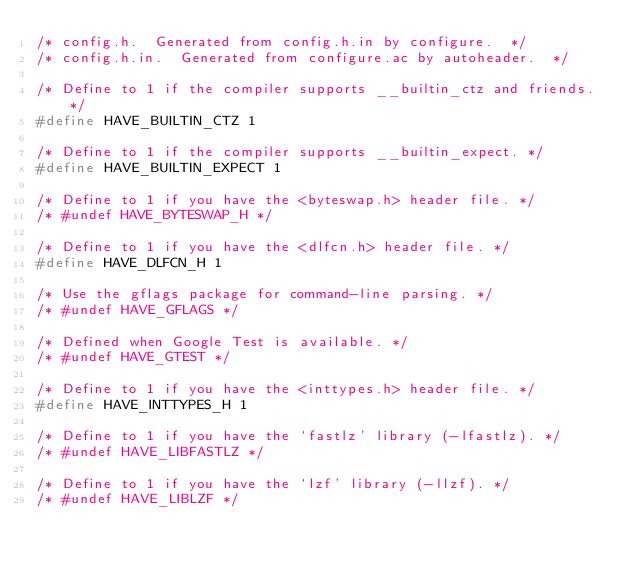<code> <loc_0><loc_0><loc_500><loc_500><_C_>/* config.h.  Generated from config.h.in by configure.  */
/* config.h.in.  Generated from configure.ac by autoheader.  */

/* Define to 1 if the compiler supports __builtin_ctz and friends. */
#define HAVE_BUILTIN_CTZ 1

/* Define to 1 if the compiler supports __builtin_expect. */
#define HAVE_BUILTIN_EXPECT 1

/* Define to 1 if you have the <byteswap.h> header file. */
/* #undef HAVE_BYTESWAP_H */

/* Define to 1 if you have the <dlfcn.h> header file. */
#define HAVE_DLFCN_H 1

/* Use the gflags package for command-line parsing. */
/* #undef HAVE_GFLAGS */

/* Defined when Google Test is available. */
/* #undef HAVE_GTEST */

/* Define to 1 if you have the <inttypes.h> header file. */
#define HAVE_INTTYPES_H 1

/* Define to 1 if you have the `fastlz' library (-lfastlz). */
/* #undef HAVE_LIBFASTLZ */

/* Define to 1 if you have the `lzf' library (-llzf). */
/* #undef HAVE_LIBLZF */
</code> 